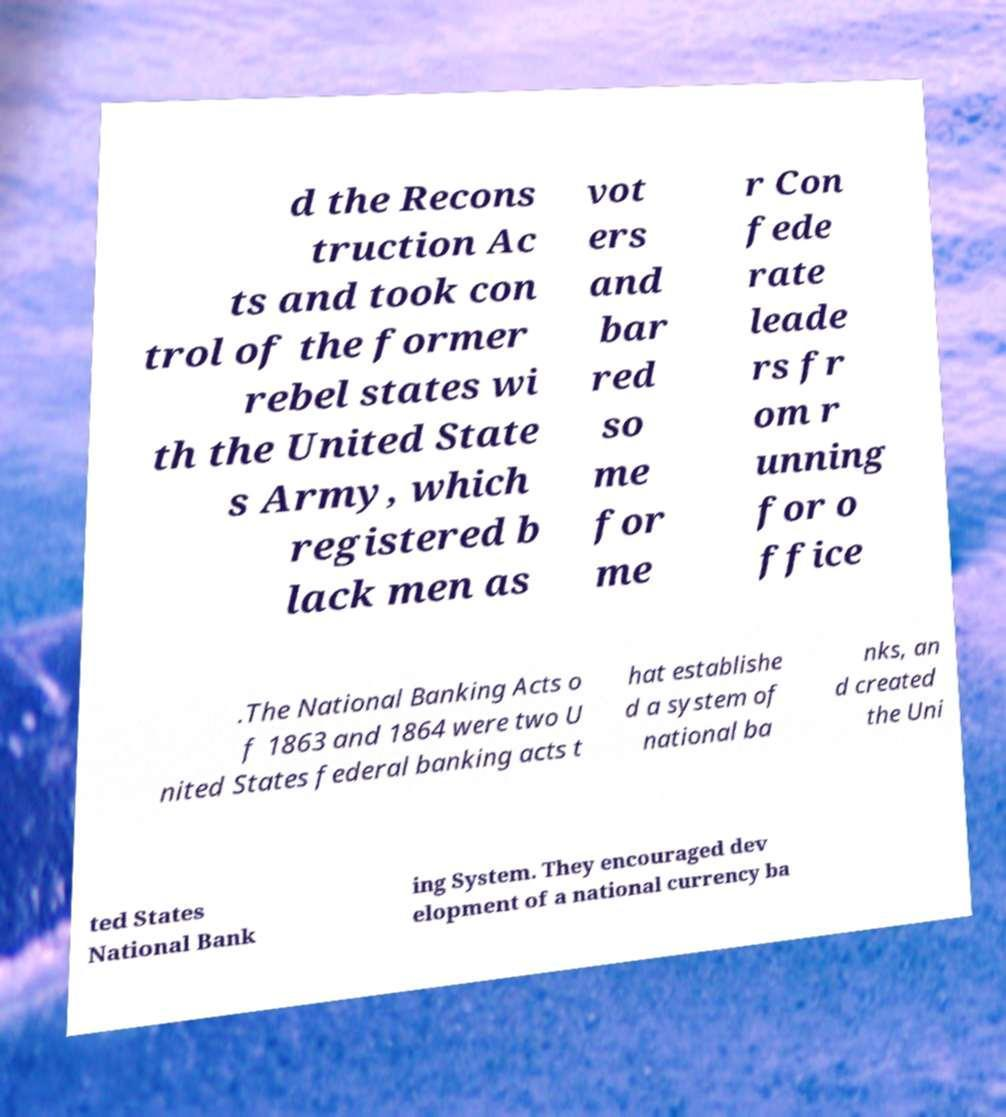What messages or text are displayed in this image? I need them in a readable, typed format. d the Recons truction Ac ts and took con trol of the former rebel states wi th the United State s Army, which registered b lack men as vot ers and bar red so me for me r Con fede rate leade rs fr om r unning for o ffice .The National Banking Acts o f 1863 and 1864 were two U nited States federal banking acts t hat establishe d a system of national ba nks, an d created the Uni ted States National Bank ing System. They encouraged dev elopment of a national currency ba 